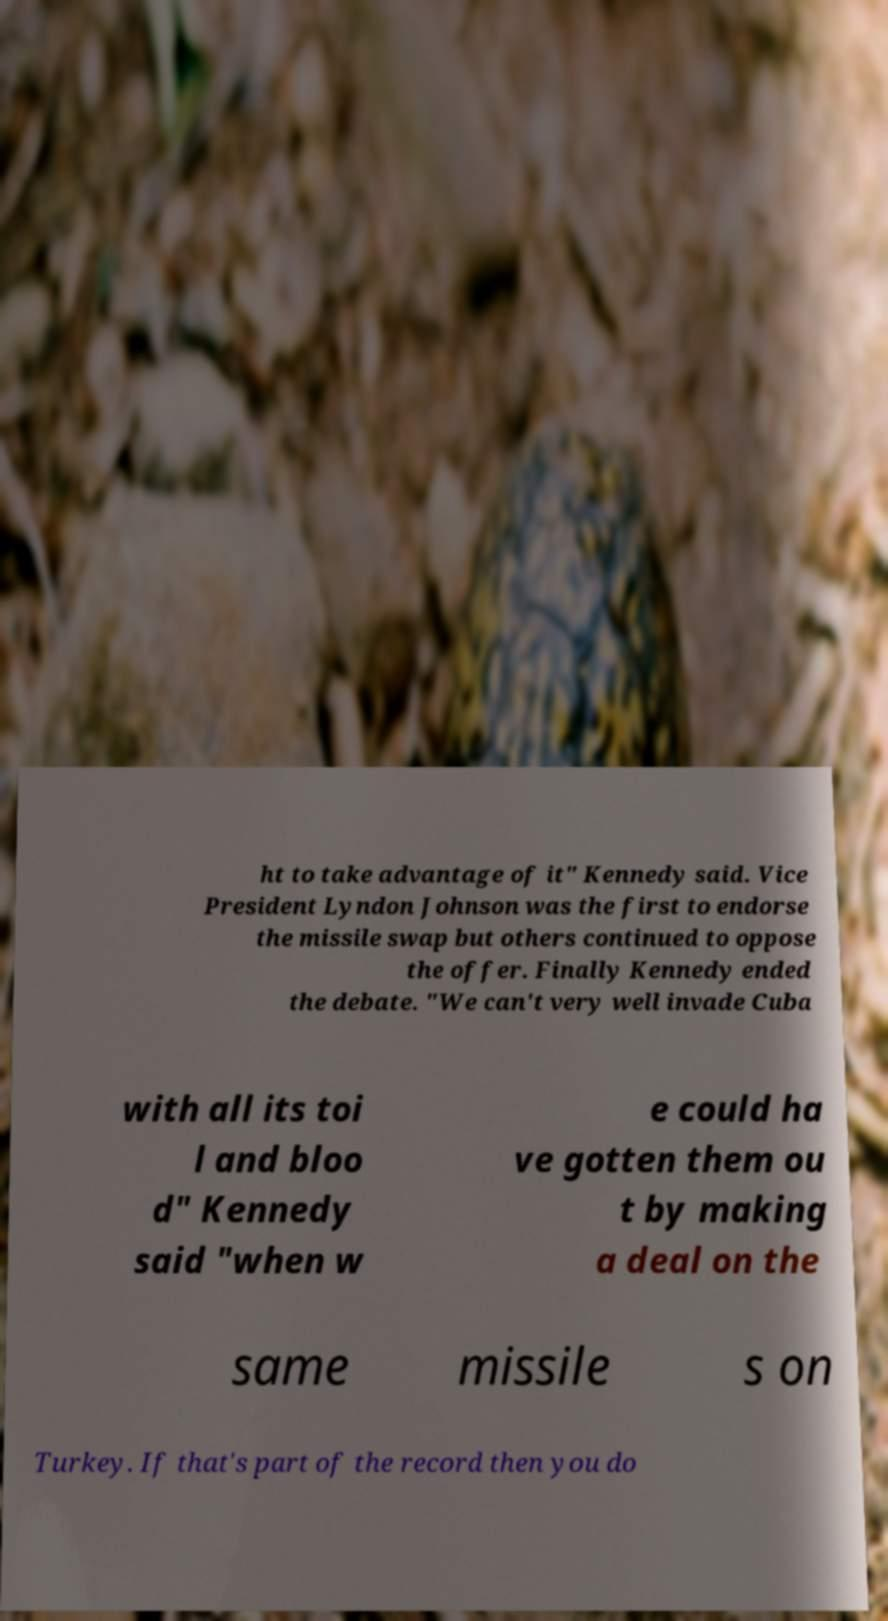I need the written content from this picture converted into text. Can you do that? ht to take advantage of it" Kennedy said. Vice President Lyndon Johnson was the first to endorse the missile swap but others continued to oppose the offer. Finally Kennedy ended the debate. "We can't very well invade Cuba with all its toi l and bloo d" Kennedy said "when w e could ha ve gotten them ou t by making a deal on the same missile s on Turkey. If that's part of the record then you do 